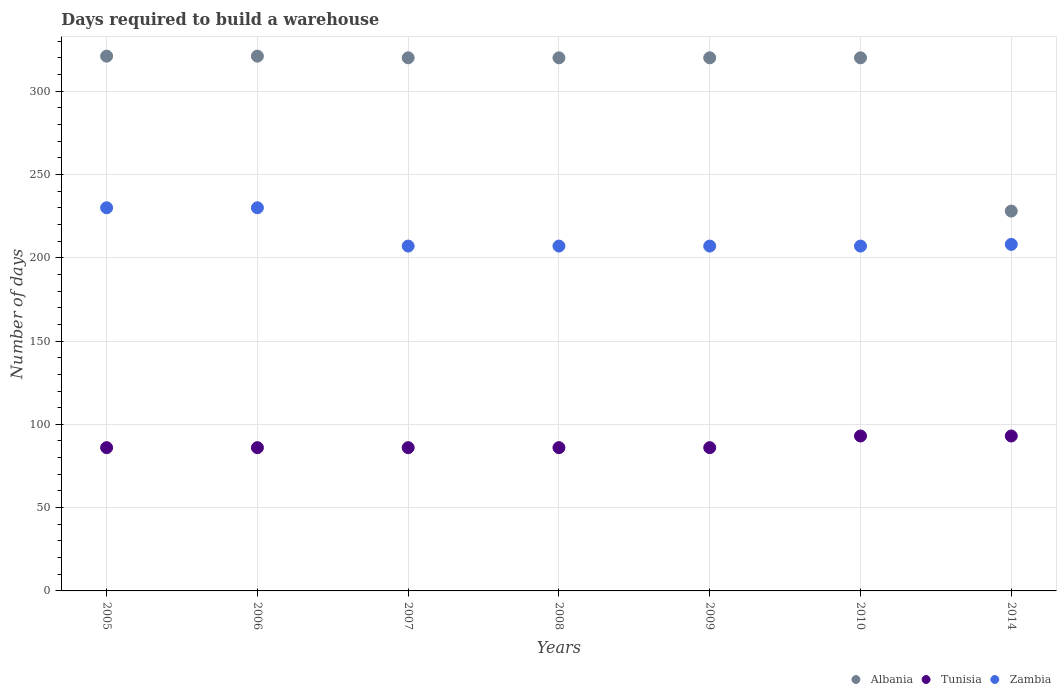What is the days required to build a warehouse in in Tunisia in 2005?
Offer a very short reply. 86. Across all years, what is the maximum days required to build a warehouse in in Tunisia?
Your answer should be very brief. 93. Across all years, what is the minimum days required to build a warehouse in in Tunisia?
Ensure brevity in your answer.  86. In which year was the days required to build a warehouse in in Albania maximum?
Provide a short and direct response. 2005. What is the total days required to build a warehouse in in Zambia in the graph?
Make the answer very short. 1496. What is the difference between the days required to build a warehouse in in Albania in 2007 and that in 2009?
Offer a terse response. 0. What is the difference between the days required to build a warehouse in in Tunisia in 2006 and the days required to build a warehouse in in Albania in 2005?
Your answer should be compact. -235. What is the average days required to build a warehouse in in Albania per year?
Give a very brief answer. 307.14. In the year 2009, what is the difference between the days required to build a warehouse in in Tunisia and days required to build a warehouse in in Zambia?
Your response must be concise. -121. What is the ratio of the days required to build a warehouse in in Albania in 2006 to that in 2014?
Ensure brevity in your answer.  1.41. Is the difference between the days required to build a warehouse in in Tunisia in 2007 and 2010 greater than the difference between the days required to build a warehouse in in Zambia in 2007 and 2010?
Provide a succinct answer. No. What is the difference between the highest and the second highest days required to build a warehouse in in Tunisia?
Keep it short and to the point. 0. What is the difference between the highest and the lowest days required to build a warehouse in in Albania?
Keep it short and to the point. 93. In how many years, is the days required to build a warehouse in in Zambia greater than the average days required to build a warehouse in in Zambia taken over all years?
Ensure brevity in your answer.  2. Is it the case that in every year, the sum of the days required to build a warehouse in in Albania and days required to build a warehouse in in Zambia  is greater than the days required to build a warehouse in in Tunisia?
Offer a very short reply. Yes. How many years are there in the graph?
Give a very brief answer. 7. What is the difference between two consecutive major ticks on the Y-axis?
Ensure brevity in your answer.  50. Does the graph contain any zero values?
Offer a terse response. No. Does the graph contain grids?
Offer a terse response. Yes. Where does the legend appear in the graph?
Make the answer very short. Bottom right. What is the title of the graph?
Provide a short and direct response. Days required to build a warehouse. What is the label or title of the Y-axis?
Make the answer very short. Number of days. What is the Number of days in Albania in 2005?
Make the answer very short. 321. What is the Number of days in Tunisia in 2005?
Your response must be concise. 86. What is the Number of days of Zambia in 2005?
Your answer should be compact. 230. What is the Number of days in Albania in 2006?
Your answer should be very brief. 321. What is the Number of days in Tunisia in 2006?
Your answer should be compact. 86. What is the Number of days of Zambia in 2006?
Make the answer very short. 230. What is the Number of days in Albania in 2007?
Make the answer very short. 320. What is the Number of days of Zambia in 2007?
Keep it short and to the point. 207. What is the Number of days in Albania in 2008?
Your answer should be compact. 320. What is the Number of days in Zambia in 2008?
Provide a succinct answer. 207. What is the Number of days in Albania in 2009?
Your answer should be very brief. 320. What is the Number of days in Zambia in 2009?
Offer a very short reply. 207. What is the Number of days of Albania in 2010?
Ensure brevity in your answer.  320. What is the Number of days in Tunisia in 2010?
Make the answer very short. 93. What is the Number of days in Zambia in 2010?
Ensure brevity in your answer.  207. What is the Number of days in Albania in 2014?
Your answer should be very brief. 228. What is the Number of days of Tunisia in 2014?
Provide a succinct answer. 93. What is the Number of days in Zambia in 2014?
Give a very brief answer. 208. Across all years, what is the maximum Number of days in Albania?
Your answer should be compact. 321. Across all years, what is the maximum Number of days in Tunisia?
Your answer should be compact. 93. Across all years, what is the maximum Number of days in Zambia?
Offer a terse response. 230. Across all years, what is the minimum Number of days of Albania?
Keep it short and to the point. 228. Across all years, what is the minimum Number of days in Zambia?
Make the answer very short. 207. What is the total Number of days in Albania in the graph?
Make the answer very short. 2150. What is the total Number of days in Tunisia in the graph?
Your answer should be very brief. 616. What is the total Number of days in Zambia in the graph?
Your answer should be compact. 1496. What is the difference between the Number of days in Albania in 2005 and that in 2006?
Make the answer very short. 0. What is the difference between the Number of days of Albania in 2005 and that in 2008?
Keep it short and to the point. 1. What is the difference between the Number of days of Zambia in 2005 and that in 2008?
Your answer should be very brief. 23. What is the difference between the Number of days of Albania in 2005 and that in 2009?
Your answer should be very brief. 1. What is the difference between the Number of days in Tunisia in 2005 and that in 2009?
Provide a short and direct response. 0. What is the difference between the Number of days in Zambia in 2005 and that in 2009?
Your response must be concise. 23. What is the difference between the Number of days of Tunisia in 2005 and that in 2010?
Keep it short and to the point. -7. What is the difference between the Number of days in Zambia in 2005 and that in 2010?
Provide a short and direct response. 23. What is the difference between the Number of days in Albania in 2005 and that in 2014?
Make the answer very short. 93. What is the difference between the Number of days of Tunisia in 2005 and that in 2014?
Your answer should be very brief. -7. What is the difference between the Number of days of Zambia in 2005 and that in 2014?
Provide a succinct answer. 22. What is the difference between the Number of days of Albania in 2006 and that in 2007?
Give a very brief answer. 1. What is the difference between the Number of days of Tunisia in 2006 and that in 2007?
Your answer should be compact. 0. What is the difference between the Number of days of Zambia in 2006 and that in 2007?
Give a very brief answer. 23. What is the difference between the Number of days of Zambia in 2006 and that in 2008?
Ensure brevity in your answer.  23. What is the difference between the Number of days of Tunisia in 2006 and that in 2009?
Offer a terse response. 0. What is the difference between the Number of days of Zambia in 2006 and that in 2009?
Offer a very short reply. 23. What is the difference between the Number of days in Tunisia in 2006 and that in 2010?
Offer a terse response. -7. What is the difference between the Number of days in Zambia in 2006 and that in 2010?
Your response must be concise. 23. What is the difference between the Number of days in Albania in 2006 and that in 2014?
Your response must be concise. 93. What is the difference between the Number of days of Tunisia in 2006 and that in 2014?
Offer a terse response. -7. What is the difference between the Number of days of Albania in 2007 and that in 2008?
Make the answer very short. 0. What is the difference between the Number of days in Zambia in 2007 and that in 2008?
Your answer should be compact. 0. What is the difference between the Number of days in Albania in 2007 and that in 2010?
Your answer should be very brief. 0. What is the difference between the Number of days of Albania in 2007 and that in 2014?
Your answer should be compact. 92. What is the difference between the Number of days of Tunisia in 2007 and that in 2014?
Give a very brief answer. -7. What is the difference between the Number of days of Zambia in 2007 and that in 2014?
Make the answer very short. -1. What is the difference between the Number of days of Tunisia in 2008 and that in 2009?
Your response must be concise. 0. What is the difference between the Number of days in Zambia in 2008 and that in 2009?
Ensure brevity in your answer.  0. What is the difference between the Number of days of Tunisia in 2008 and that in 2010?
Make the answer very short. -7. What is the difference between the Number of days of Zambia in 2008 and that in 2010?
Offer a terse response. 0. What is the difference between the Number of days in Albania in 2008 and that in 2014?
Your answer should be very brief. 92. What is the difference between the Number of days of Tunisia in 2008 and that in 2014?
Offer a terse response. -7. What is the difference between the Number of days in Tunisia in 2009 and that in 2010?
Offer a terse response. -7. What is the difference between the Number of days of Zambia in 2009 and that in 2010?
Make the answer very short. 0. What is the difference between the Number of days in Albania in 2009 and that in 2014?
Your response must be concise. 92. What is the difference between the Number of days in Zambia in 2009 and that in 2014?
Provide a short and direct response. -1. What is the difference between the Number of days of Albania in 2010 and that in 2014?
Make the answer very short. 92. What is the difference between the Number of days of Albania in 2005 and the Number of days of Tunisia in 2006?
Give a very brief answer. 235. What is the difference between the Number of days of Albania in 2005 and the Number of days of Zambia in 2006?
Give a very brief answer. 91. What is the difference between the Number of days of Tunisia in 2005 and the Number of days of Zambia in 2006?
Give a very brief answer. -144. What is the difference between the Number of days in Albania in 2005 and the Number of days in Tunisia in 2007?
Offer a very short reply. 235. What is the difference between the Number of days in Albania in 2005 and the Number of days in Zambia in 2007?
Keep it short and to the point. 114. What is the difference between the Number of days in Tunisia in 2005 and the Number of days in Zambia in 2007?
Keep it short and to the point. -121. What is the difference between the Number of days of Albania in 2005 and the Number of days of Tunisia in 2008?
Make the answer very short. 235. What is the difference between the Number of days of Albania in 2005 and the Number of days of Zambia in 2008?
Your answer should be compact. 114. What is the difference between the Number of days in Tunisia in 2005 and the Number of days in Zambia in 2008?
Your response must be concise. -121. What is the difference between the Number of days in Albania in 2005 and the Number of days in Tunisia in 2009?
Give a very brief answer. 235. What is the difference between the Number of days of Albania in 2005 and the Number of days of Zambia in 2009?
Provide a short and direct response. 114. What is the difference between the Number of days of Tunisia in 2005 and the Number of days of Zambia in 2009?
Keep it short and to the point. -121. What is the difference between the Number of days in Albania in 2005 and the Number of days in Tunisia in 2010?
Offer a terse response. 228. What is the difference between the Number of days in Albania in 2005 and the Number of days in Zambia in 2010?
Provide a short and direct response. 114. What is the difference between the Number of days of Tunisia in 2005 and the Number of days of Zambia in 2010?
Make the answer very short. -121. What is the difference between the Number of days of Albania in 2005 and the Number of days of Tunisia in 2014?
Your answer should be compact. 228. What is the difference between the Number of days in Albania in 2005 and the Number of days in Zambia in 2014?
Your answer should be very brief. 113. What is the difference between the Number of days of Tunisia in 2005 and the Number of days of Zambia in 2014?
Keep it short and to the point. -122. What is the difference between the Number of days in Albania in 2006 and the Number of days in Tunisia in 2007?
Your answer should be compact. 235. What is the difference between the Number of days in Albania in 2006 and the Number of days in Zambia in 2007?
Your response must be concise. 114. What is the difference between the Number of days of Tunisia in 2006 and the Number of days of Zambia in 2007?
Keep it short and to the point. -121. What is the difference between the Number of days of Albania in 2006 and the Number of days of Tunisia in 2008?
Keep it short and to the point. 235. What is the difference between the Number of days in Albania in 2006 and the Number of days in Zambia in 2008?
Offer a very short reply. 114. What is the difference between the Number of days of Tunisia in 2006 and the Number of days of Zambia in 2008?
Give a very brief answer. -121. What is the difference between the Number of days of Albania in 2006 and the Number of days of Tunisia in 2009?
Your response must be concise. 235. What is the difference between the Number of days of Albania in 2006 and the Number of days of Zambia in 2009?
Give a very brief answer. 114. What is the difference between the Number of days in Tunisia in 2006 and the Number of days in Zambia in 2009?
Ensure brevity in your answer.  -121. What is the difference between the Number of days of Albania in 2006 and the Number of days of Tunisia in 2010?
Your answer should be very brief. 228. What is the difference between the Number of days of Albania in 2006 and the Number of days of Zambia in 2010?
Keep it short and to the point. 114. What is the difference between the Number of days of Tunisia in 2006 and the Number of days of Zambia in 2010?
Your answer should be very brief. -121. What is the difference between the Number of days in Albania in 2006 and the Number of days in Tunisia in 2014?
Your answer should be very brief. 228. What is the difference between the Number of days of Albania in 2006 and the Number of days of Zambia in 2014?
Keep it short and to the point. 113. What is the difference between the Number of days of Tunisia in 2006 and the Number of days of Zambia in 2014?
Your answer should be very brief. -122. What is the difference between the Number of days in Albania in 2007 and the Number of days in Tunisia in 2008?
Ensure brevity in your answer.  234. What is the difference between the Number of days in Albania in 2007 and the Number of days in Zambia in 2008?
Your response must be concise. 113. What is the difference between the Number of days of Tunisia in 2007 and the Number of days of Zambia in 2008?
Keep it short and to the point. -121. What is the difference between the Number of days of Albania in 2007 and the Number of days of Tunisia in 2009?
Ensure brevity in your answer.  234. What is the difference between the Number of days of Albania in 2007 and the Number of days of Zambia in 2009?
Your response must be concise. 113. What is the difference between the Number of days of Tunisia in 2007 and the Number of days of Zambia in 2009?
Provide a succinct answer. -121. What is the difference between the Number of days in Albania in 2007 and the Number of days in Tunisia in 2010?
Your answer should be very brief. 227. What is the difference between the Number of days in Albania in 2007 and the Number of days in Zambia in 2010?
Provide a short and direct response. 113. What is the difference between the Number of days in Tunisia in 2007 and the Number of days in Zambia in 2010?
Make the answer very short. -121. What is the difference between the Number of days in Albania in 2007 and the Number of days in Tunisia in 2014?
Keep it short and to the point. 227. What is the difference between the Number of days in Albania in 2007 and the Number of days in Zambia in 2014?
Your answer should be very brief. 112. What is the difference between the Number of days of Tunisia in 2007 and the Number of days of Zambia in 2014?
Your answer should be compact. -122. What is the difference between the Number of days in Albania in 2008 and the Number of days in Tunisia in 2009?
Ensure brevity in your answer.  234. What is the difference between the Number of days of Albania in 2008 and the Number of days of Zambia in 2009?
Provide a short and direct response. 113. What is the difference between the Number of days of Tunisia in 2008 and the Number of days of Zambia in 2009?
Ensure brevity in your answer.  -121. What is the difference between the Number of days in Albania in 2008 and the Number of days in Tunisia in 2010?
Offer a terse response. 227. What is the difference between the Number of days in Albania in 2008 and the Number of days in Zambia in 2010?
Keep it short and to the point. 113. What is the difference between the Number of days in Tunisia in 2008 and the Number of days in Zambia in 2010?
Offer a terse response. -121. What is the difference between the Number of days of Albania in 2008 and the Number of days of Tunisia in 2014?
Your answer should be very brief. 227. What is the difference between the Number of days in Albania in 2008 and the Number of days in Zambia in 2014?
Provide a succinct answer. 112. What is the difference between the Number of days of Tunisia in 2008 and the Number of days of Zambia in 2014?
Your response must be concise. -122. What is the difference between the Number of days of Albania in 2009 and the Number of days of Tunisia in 2010?
Your answer should be very brief. 227. What is the difference between the Number of days of Albania in 2009 and the Number of days of Zambia in 2010?
Give a very brief answer. 113. What is the difference between the Number of days of Tunisia in 2009 and the Number of days of Zambia in 2010?
Provide a succinct answer. -121. What is the difference between the Number of days in Albania in 2009 and the Number of days in Tunisia in 2014?
Your response must be concise. 227. What is the difference between the Number of days of Albania in 2009 and the Number of days of Zambia in 2014?
Keep it short and to the point. 112. What is the difference between the Number of days of Tunisia in 2009 and the Number of days of Zambia in 2014?
Keep it short and to the point. -122. What is the difference between the Number of days of Albania in 2010 and the Number of days of Tunisia in 2014?
Your answer should be compact. 227. What is the difference between the Number of days in Albania in 2010 and the Number of days in Zambia in 2014?
Offer a terse response. 112. What is the difference between the Number of days in Tunisia in 2010 and the Number of days in Zambia in 2014?
Keep it short and to the point. -115. What is the average Number of days in Albania per year?
Give a very brief answer. 307.14. What is the average Number of days of Tunisia per year?
Make the answer very short. 88. What is the average Number of days in Zambia per year?
Keep it short and to the point. 213.71. In the year 2005, what is the difference between the Number of days of Albania and Number of days of Tunisia?
Ensure brevity in your answer.  235. In the year 2005, what is the difference between the Number of days of Albania and Number of days of Zambia?
Offer a terse response. 91. In the year 2005, what is the difference between the Number of days in Tunisia and Number of days in Zambia?
Make the answer very short. -144. In the year 2006, what is the difference between the Number of days of Albania and Number of days of Tunisia?
Offer a terse response. 235. In the year 2006, what is the difference between the Number of days in Albania and Number of days in Zambia?
Give a very brief answer. 91. In the year 2006, what is the difference between the Number of days of Tunisia and Number of days of Zambia?
Offer a terse response. -144. In the year 2007, what is the difference between the Number of days in Albania and Number of days in Tunisia?
Your response must be concise. 234. In the year 2007, what is the difference between the Number of days of Albania and Number of days of Zambia?
Your response must be concise. 113. In the year 2007, what is the difference between the Number of days in Tunisia and Number of days in Zambia?
Your response must be concise. -121. In the year 2008, what is the difference between the Number of days of Albania and Number of days of Tunisia?
Offer a terse response. 234. In the year 2008, what is the difference between the Number of days of Albania and Number of days of Zambia?
Provide a succinct answer. 113. In the year 2008, what is the difference between the Number of days of Tunisia and Number of days of Zambia?
Give a very brief answer. -121. In the year 2009, what is the difference between the Number of days of Albania and Number of days of Tunisia?
Give a very brief answer. 234. In the year 2009, what is the difference between the Number of days of Albania and Number of days of Zambia?
Your answer should be very brief. 113. In the year 2009, what is the difference between the Number of days of Tunisia and Number of days of Zambia?
Give a very brief answer. -121. In the year 2010, what is the difference between the Number of days in Albania and Number of days in Tunisia?
Provide a succinct answer. 227. In the year 2010, what is the difference between the Number of days in Albania and Number of days in Zambia?
Make the answer very short. 113. In the year 2010, what is the difference between the Number of days in Tunisia and Number of days in Zambia?
Provide a short and direct response. -114. In the year 2014, what is the difference between the Number of days in Albania and Number of days in Tunisia?
Offer a very short reply. 135. In the year 2014, what is the difference between the Number of days in Albania and Number of days in Zambia?
Your answer should be very brief. 20. In the year 2014, what is the difference between the Number of days of Tunisia and Number of days of Zambia?
Ensure brevity in your answer.  -115. What is the ratio of the Number of days of Albania in 2005 to that in 2006?
Keep it short and to the point. 1. What is the ratio of the Number of days of Tunisia in 2005 to that in 2006?
Your response must be concise. 1. What is the ratio of the Number of days of Tunisia in 2005 to that in 2007?
Make the answer very short. 1. What is the ratio of the Number of days in Albania in 2005 to that in 2008?
Make the answer very short. 1. What is the ratio of the Number of days in Tunisia in 2005 to that in 2008?
Your answer should be very brief. 1. What is the ratio of the Number of days in Tunisia in 2005 to that in 2009?
Your response must be concise. 1. What is the ratio of the Number of days in Albania in 2005 to that in 2010?
Keep it short and to the point. 1. What is the ratio of the Number of days of Tunisia in 2005 to that in 2010?
Keep it short and to the point. 0.92. What is the ratio of the Number of days of Albania in 2005 to that in 2014?
Offer a terse response. 1.41. What is the ratio of the Number of days in Tunisia in 2005 to that in 2014?
Keep it short and to the point. 0.92. What is the ratio of the Number of days in Zambia in 2005 to that in 2014?
Make the answer very short. 1.11. What is the ratio of the Number of days of Albania in 2006 to that in 2007?
Make the answer very short. 1. What is the ratio of the Number of days in Zambia in 2006 to that in 2007?
Make the answer very short. 1.11. What is the ratio of the Number of days in Albania in 2006 to that in 2008?
Offer a terse response. 1. What is the ratio of the Number of days in Tunisia in 2006 to that in 2008?
Your answer should be very brief. 1. What is the ratio of the Number of days of Albania in 2006 to that in 2009?
Provide a short and direct response. 1. What is the ratio of the Number of days of Zambia in 2006 to that in 2009?
Ensure brevity in your answer.  1.11. What is the ratio of the Number of days of Tunisia in 2006 to that in 2010?
Your answer should be very brief. 0.92. What is the ratio of the Number of days in Zambia in 2006 to that in 2010?
Provide a succinct answer. 1.11. What is the ratio of the Number of days in Albania in 2006 to that in 2014?
Provide a succinct answer. 1.41. What is the ratio of the Number of days of Tunisia in 2006 to that in 2014?
Your response must be concise. 0.92. What is the ratio of the Number of days in Zambia in 2006 to that in 2014?
Give a very brief answer. 1.11. What is the ratio of the Number of days in Albania in 2007 to that in 2008?
Provide a short and direct response. 1. What is the ratio of the Number of days of Albania in 2007 to that in 2009?
Keep it short and to the point. 1. What is the ratio of the Number of days of Albania in 2007 to that in 2010?
Make the answer very short. 1. What is the ratio of the Number of days of Tunisia in 2007 to that in 2010?
Provide a short and direct response. 0.92. What is the ratio of the Number of days of Albania in 2007 to that in 2014?
Provide a succinct answer. 1.4. What is the ratio of the Number of days of Tunisia in 2007 to that in 2014?
Keep it short and to the point. 0.92. What is the ratio of the Number of days of Tunisia in 2008 to that in 2009?
Your answer should be very brief. 1. What is the ratio of the Number of days in Albania in 2008 to that in 2010?
Provide a short and direct response. 1. What is the ratio of the Number of days of Tunisia in 2008 to that in 2010?
Make the answer very short. 0.92. What is the ratio of the Number of days of Zambia in 2008 to that in 2010?
Your response must be concise. 1. What is the ratio of the Number of days of Albania in 2008 to that in 2014?
Give a very brief answer. 1.4. What is the ratio of the Number of days of Tunisia in 2008 to that in 2014?
Ensure brevity in your answer.  0.92. What is the ratio of the Number of days in Zambia in 2008 to that in 2014?
Provide a short and direct response. 1. What is the ratio of the Number of days in Tunisia in 2009 to that in 2010?
Keep it short and to the point. 0.92. What is the ratio of the Number of days of Zambia in 2009 to that in 2010?
Your answer should be very brief. 1. What is the ratio of the Number of days of Albania in 2009 to that in 2014?
Your answer should be very brief. 1.4. What is the ratio of the Number of days of Tunisia in 2009 to that in 2014?
Offer a terse response. 0.92. What is the ratio of the Number of days in Albania in 2010 to that in 2014?
Provide a succinct answer. 1.4. What is the ratio of the Number of days in Zambia in 2010 to that in 2014?
Provide a succinct answer. 1. What is the difference between the highest and the second highest Number of days in Albania?
Offer a very short reply. 0. What is the difference between the highest and the second highest Number of days in Zambia?
Your answer should be compact. 0. What is the difference between the highest and the lowest Number of days in Albania?
Ensure brevity in your answer.  93. 